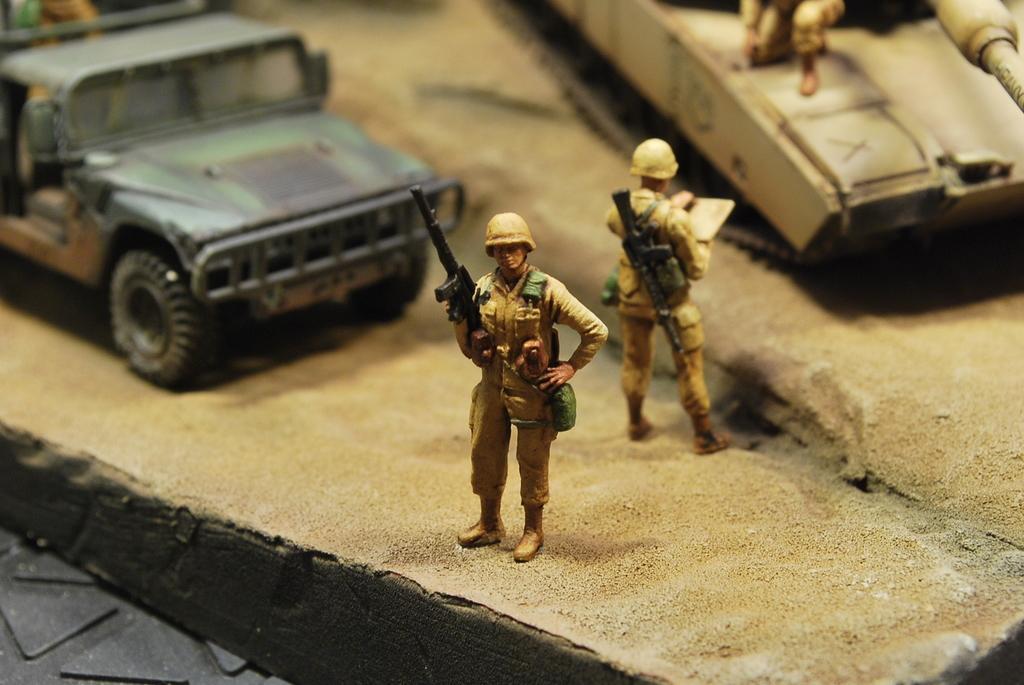Please provide a concise description of this image. In the center of this picture we can see the toys of persons holding some objects and standing. On the left we can see the vehicle. On the right there is an object seems to be the tank. 